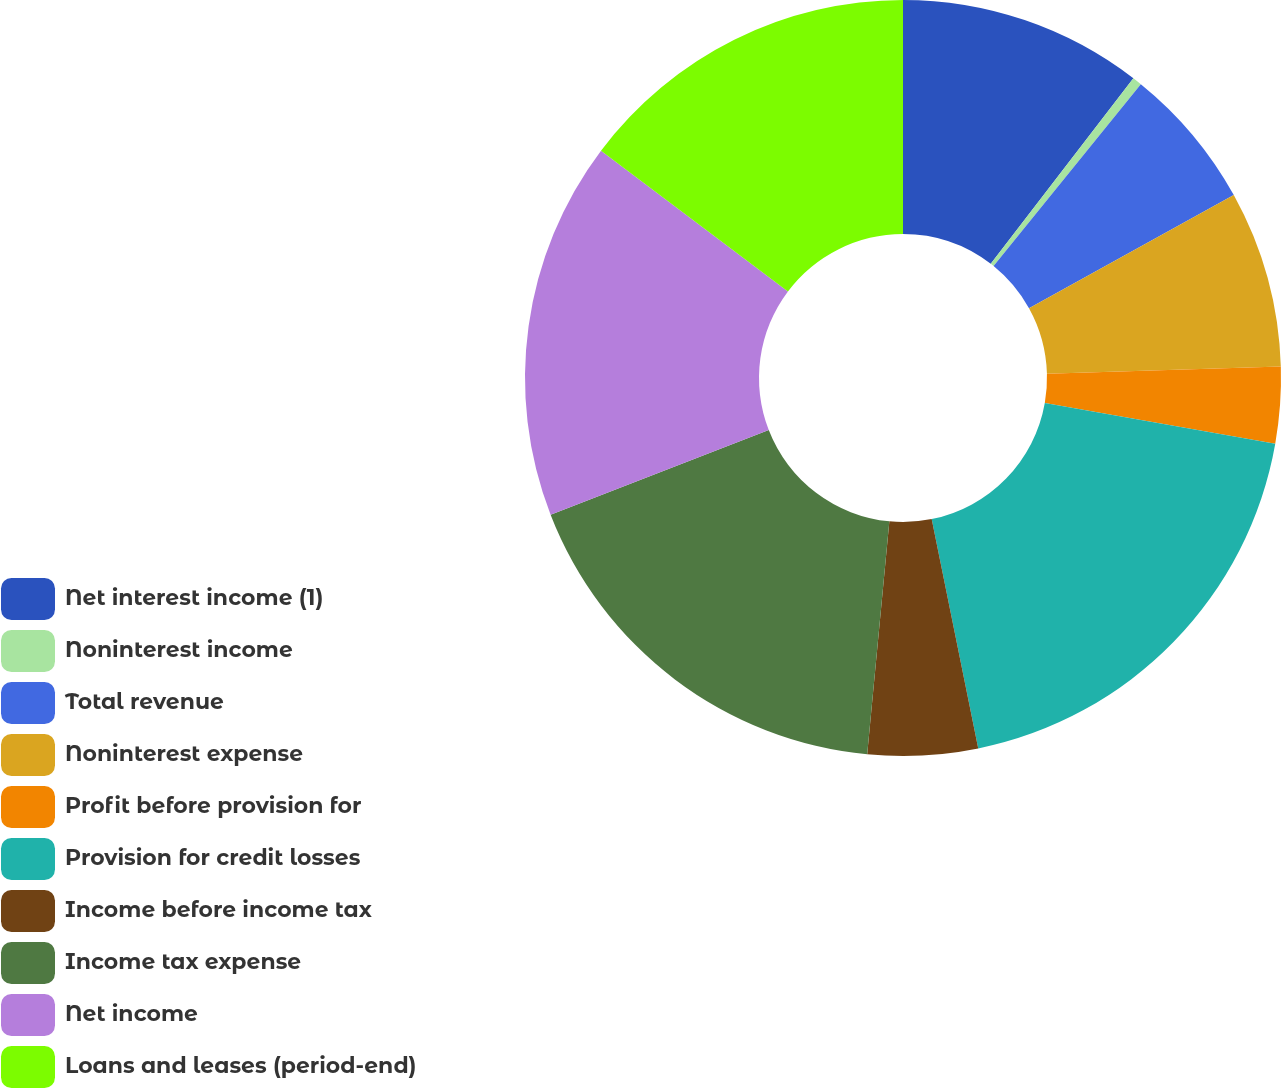Convert chart. <chart><loc_0><loc_0><loc_500><loc_500><pie_chart><fcel>Net interest income (1)<fcel>Noninterest income<fcel>Total revenue<fcel>Noninterest expense<fcel>Profit before provision for<fcel>Provision for credit losses<fcel>Income before income tax<fcel>Income tax expense<fcel>Net income<fcel>Loans and leases (period-end)<nl><fcel>10.43%<fcel>0.4%<fcel>6.13%<fcel>7.56%<fcel>3.26%<fcel>19.03%<fcel>4.7%<fcel>17.6%<fcel>16.16%<fcel>14.73%<nl></chart> 